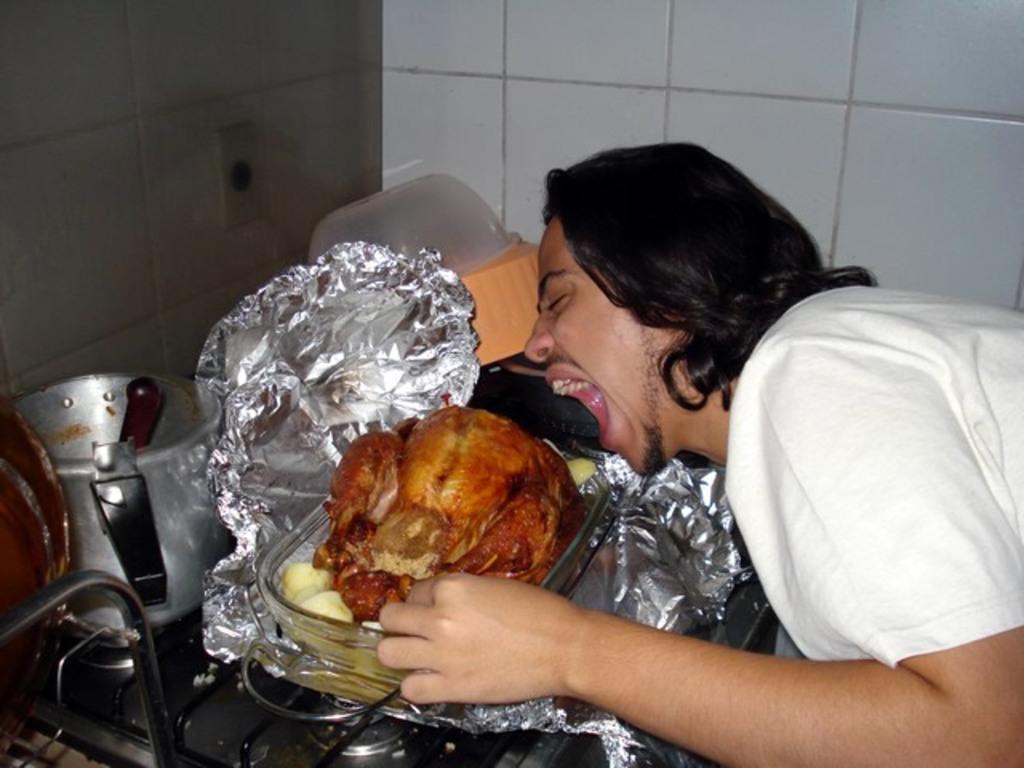Could you give a brief overview of what you see in this image? On the right side of the image a person is there. In the center of the image we can see vessels, paper, meat, containers, stove are present. At the top of the image wall is there. 